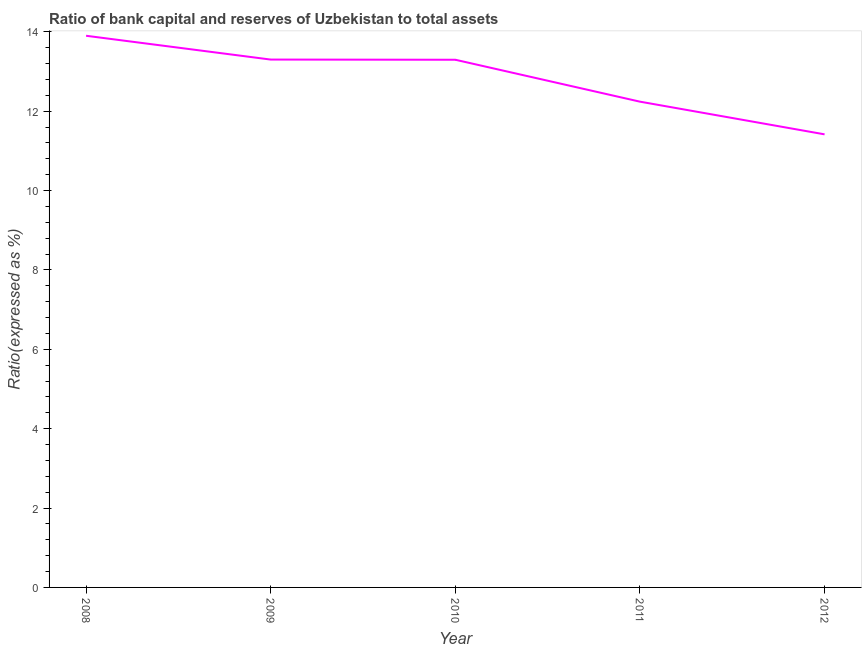What is the bank capital to assets ratio in 2011?
Provide a short and direct response. 12.24. Across all years, what is the maximum bank capital to assets ratio?
Make the answer very short. 13.9. Across all years, what is the minimum bank capital to assets ratio?
Keep it short and to the point. 11.42. What is the sum of the bank capital to assets ratio?
Your response must be concise. 64.15. What is the difference between the bank capital to assets ratio in 2008 and 2011?
Offer a terse response. 1.66. What is the average bank capital to assets ratio per year?
Offer a very short reply. 12.83. What is the median bank capital to assets ratio?
Offer a terse response. 13.3. In how many years, is the bank capital to assets ratio greater than 8.4 %?
Offer a very short reply. 5. Do a majority of the years between 2009 and 2011 (inclusive) have bank capital to assets ratio greater than 12 %?
Your answer should be compact. Yes. What is the ratio of the bank capital to assets ratio in 2009 to that in 2012?
Your answer should be very brief. 1.17. Is the bank capital to assets ratio in 2009 less than that in 2012?
Keep it short and to the point. No. Is the difference between the bank capital to assets ratio in 2008 and 2012 greater than the difference between any two years?
Provide a short and direct response. Yes. What is the difference between the highest and the second highest bank capital to assets ratio?
Your answer should be compact. 0.6. What is the difference between the highest and the lowest bank capital to assets ratio?
Keep it short and to the point. 2.48. In how many years, is the bank capital to assets ratio greater than the average bank capital to assets ratio taken over all years?
Provide a short and direct response. 3. What is the difference between two consecutive major ticks on the Y-axis?
Your answer should be very brief. 2. Does the graph contain grids?
Your response must be concise. No. What is the title of the graph?
Your answer should be compact. Ratio of bank capital and reserves of Uzbekistan to total assets. What is the label or title of the X-axis?
Ensure brevity in your answer.  Year. What is the label or title of the Y-axis?
Provide a short and direct response. Ratio(expressed as %). What is the Ratio(expressed as %) in 2009?
Your answer should be compact. 13.3. What is the Ratio(expressed as %) of 2010?
Provide a succinct answer. 13.3. What is the Ratio(expressed as %) of 2011?
Provide a short and direct response. 12.24. What is the Ratio(expressed as %) in 2012?
Ensure brevity in your answer.  11.42. What is the difference between the Ratio(expressed as %) in 2008 and 2010?
Provide a short and direct response. 0.6. What is the difference between the Ratio(expressed as %) in 2008 and 2011?
Offer a very short reply. 1.66. What is the difference between the Ratio(expressed as %) in 2008 and 2012?
Provide a short and direct response. 2.48. What is the difference between the Ratio(expressed as %) in 2009 and 2010?
Offer a very short reply. 0. What is the difference between the Ratio(expressed as %) in 2009 and 2011?
Your response must be concise. 1.06. What is the difference between the Ratio(expressed as %) in 2009 and 2012?
Your answer should be very brief. 1.88. What is the difference between the Ratio(expressed as %) in 2010 and 2011?
Offer a terse response. 1.06. What is the difference between the Ratio(expressed as %) in 2010 and 2012?
Your response must be concise. 1.88. What is the difference between the Ratio(expressed as %) in 2011 and 2012?
Keep it short and to the point. 0.82. What is the ratio of the Ratio(expressed as %) in 2008 to that in 2009?
Your answer should be compact. 1.04. What is the ratio of the Ratio(expressed as %) in 2008 to that in 2010?
Your response must be concise. 1.04. What is the ratio of the Ratio(expressed as %) in 2008 to that in 2011?
Your answer should be very brief. 1.14. What is the ratio of the Ratio(expressed as %) in 2008 to that in 2012?
Your answer should be very brief. 1.22. What is the ratio of the Ratio(expressed as %) in 2009 to that in 2011?
Provide a succinct answer. 1.09. What is the ratio of the Ratio(expressed as %) in 2009 to that in 2012?
Your answer should be very brief. 1.17. What is the ratio of the Ratio(expressed as %) in 2010 to that in 2011?
Make the answer very short. 1.09. What is the ratio of the Ratio(expressed as %) in 2010 to that in 2012?
Offer a very short reply. 1.17. What is the ratio of the Ratio(expressed as %) in 2011 to that in 2012?
Keep it short and to the point. 1.07. 